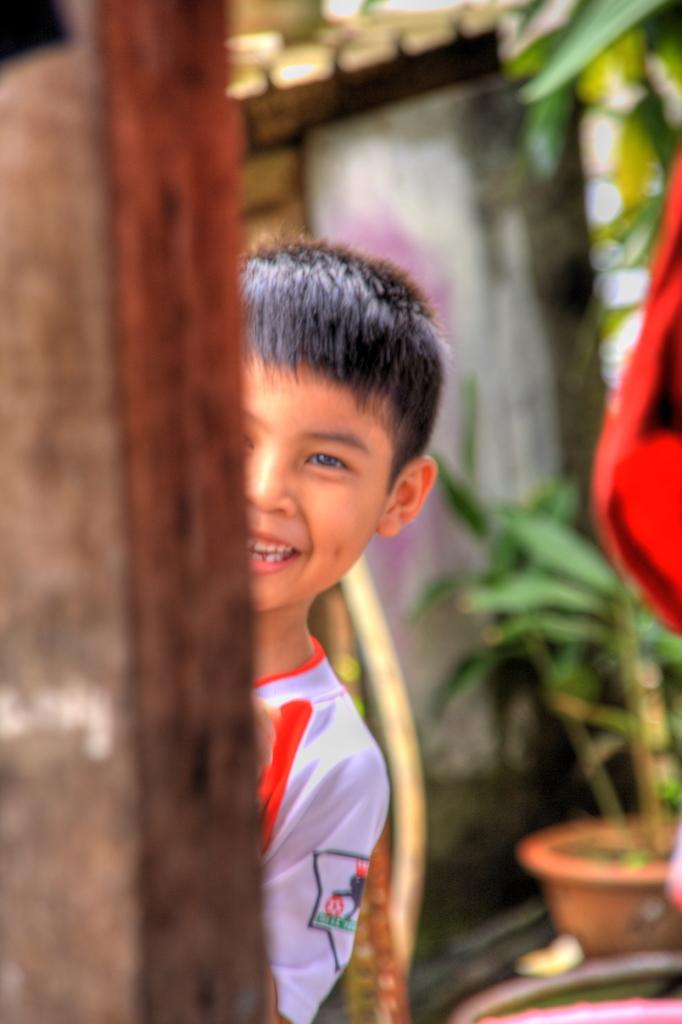What type of object is made of wood in the image? There is a wooden object in the image, but the specific type is not mentioned. How is the boy in the image feeling? The boy is smiling in the image, which suggests he is happy or content. What type of plant is present in the image? There is a house plant in the image. What can be seen in the background of the image? There are objects visible in the background of the image, but their specific nature is not mentioned. Where is the toothbrush located in the image? There is no toothbrush present in the image. What type of expansion is visible in the image? There is no expansion visible in the image. 